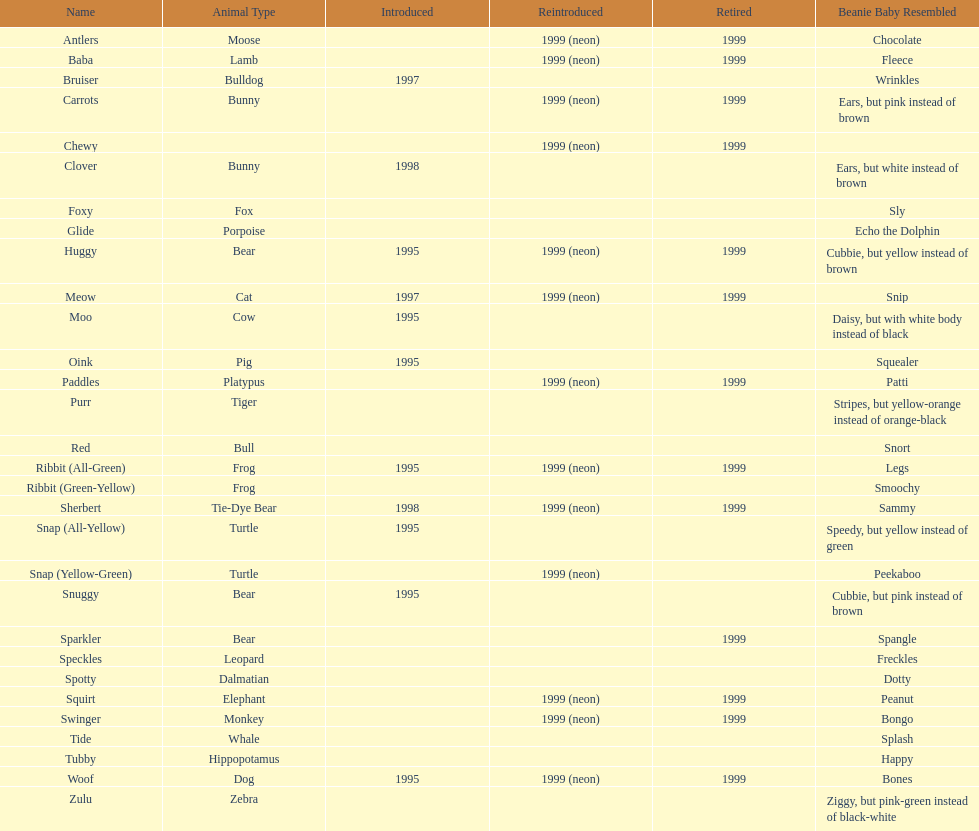Name the only pillow pal that is a dalmatian. Spotty. 